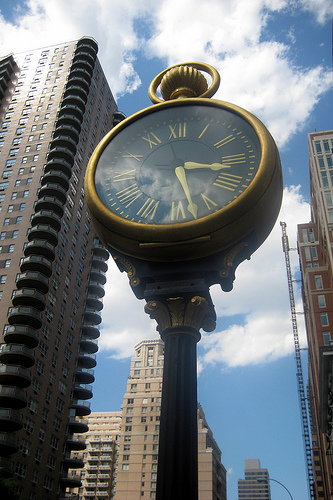<image>
Can you confirm if the building is next to the clock? Yes. The building is positioned adjacent to the clock, located nearby in the same general area. 